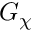<formula> <loc_0><loc_0><loc_500><loc_500>G _ { \chi }</formula> 